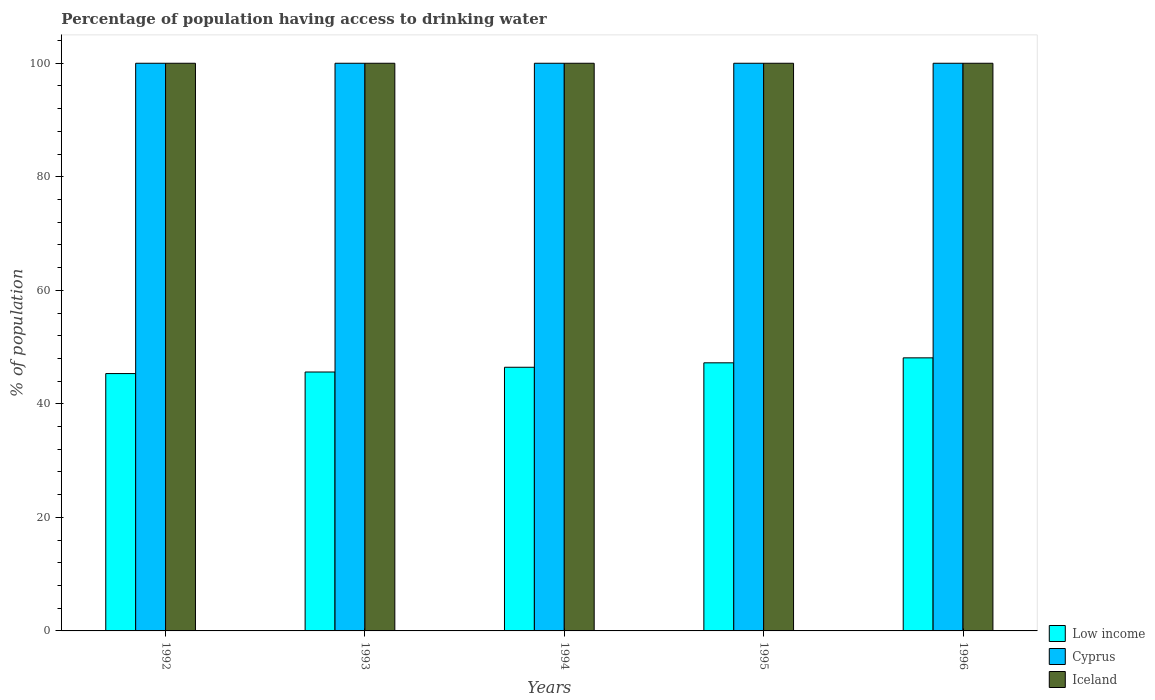Are the number of bars per tick equal to the number of legend labels?
Make the answer very short. Yes. Are the number of bars on each tick of the X-axis equal?
Give a very brief answer. Yes. What is the label of the 2nd group of bars from the left?
Provide a succinct answer. 1993. What is the percentage of population having access to drinking water in Low income in 1994?
Provide a short and direct response. 46.45. Across all years, what is the maximum percentage of population having access to drinking water in Low income?
Provide a succinct answer. 48.1. Across all years, what is the minimum percentage of population having access to drinking water in Cyprus?
Offer a terse response. 100. In which year was the percentage of population having access to drinking water in Low income maximum?
Keep it short and to the point. 1996. In which year was the percentage of population having access to drinking water in Iceland minimum?
Offer a very short reply. 1992. What is the total percentage of population having access to drinking water in Cyprus in the graph?
Offer a very short reply. 500. What is the difference between the percentage of population having access to drinking water in Low income in 1992 and the percentage of population having access to drinking water in Cyprus in 1995?
Offer a terse response. -54.67. In the year 1992, what is the difference between the percentage of population having access to drinking water in Low income and percentage of population having access to drinking water in Iceland?
Give a very brief answer. -54.67. In how many years, is the percentage of population having access to drinking water in Iceland greater than 52 %?
Make the answer very short. 5. Is the percentage of population having access to drinking water in Iceland in 1993 less than that in 1994?
Make the answer very short. No. Is the difference between the percentage of population having access to drinking water in Low income in 1995 and 1996 greater than the difference between the percentage of population having access to drinking water in Iceland in 1995 and 1996?
Make the answer very short. No. What is the difference between the highest and the lowest percentage of population having access to drinking water in Iceland?
Make the answer very short. 0. What does the 3rd bar from the left in 1996 represents?
Make the answer very short. Iceland. Is it the case that in every year, the sum of the percentage of population having access to drinking water in Cyprus and percentage of population having access to drinking water in Iceland is greater than the percentage of population having access to drinking water in Low income?
Ensure brevity in your answer.  Yes. How many bars are there?
Your response must be concise. 15. Are all the bars in the graph horizontal?
Your answer should be compact. No. Where does the legend appear in the graph?
Ensure brevity in your answer.  Bottom right. What is the title of the graph?
Make the answer very short. Percentage of population having access to drinking water. What is the label or title of the X-axis?
Your answer should be very brief. Years. What is the label or title of the Y-axis?
Offer a very short reply. % of population. What is the % of population in Low income in 1992?
Ensure brevity in your answer.  45.33. What is the % of population in Low income in 1993?
Provide a short and direct response. 45.61. What is the % of population of Low income in 1994?
Ensure brevity in your answer.  46.45. What is the % of population in Cyprus in 1994?
Give a very brief answer. 100. What is the % of population in Iceland in 1994?
Offer a terse response. 100. What is the % of population of Low income in 1995?
Make the answer very short. 47.23. What is the % of population of Iceland in 1995?
Give a very brief answer. 100. What is the % of population in Low income in 1996?
Keep it short and to the point. 48.1. What is the % of population of Cyprus in 1996?
Your answer should be very brief. 100. Across all years, what is the maximum % of population in Low income?
Your response must be concise. 48.1. Across all years, what is the maximum % of population of Cyprus?
Give a very brief answer. 100. Across all years, what is the minimum % of population of Low income?
Your response must be concise. 45.33. What is the total % of population in Low income in the graph?
Offer a terse response. 232.72. What is the total % of population of Cyprus in the graph?
Ensure brevity in your answer.  500. What is the difference between the % of population in Low income in 1992 and that in 1993?
Offer a terse response. -0.27. What is the difference between the % of population of Low income in 1992 and that in 1994?
Offer a terse response. -1.11. What is the difference between the % of population of Iceland in 1992 and that in 1994?
Make the answer very short. 0. What is the difference between the % of population in Low income in 1992 and that in 1995?
Provide a succinct answer. -1.9. What is the difference between the % of population in Cyprus in 1992 and that in 1995?
Make the answer very short. 0. What is the difference between the % of population in Low income in 1992 and that in 1996?
Provide a succinct answer. -2.77. What is the difference between the % of population in Iceland in 1992 and that in 1996?
Keep it short and to the point. 0. What is the difference between the % of population of Low income in 1993 and that in 1994?
Provide a succinct answer. -0.84. What is the difference between the % of population of Iceland in 1993 and that in 1994?
Ensure brevity in your answer.  0. What is the difference between the % of population of Low income in 1993 and that in 1995?
Offer a very short reply. -1.62. What is the difference between the % of population of Cyprus in 1993 and that in 1995?
Your answer should be very brief. 0. What is the difference between the % of population in Iceland in 1993 and that in 1995?
Offer a very short reply. 0. What is the difference between the % of population in Low income in 1993 and that in 1996?
Make the answer very short. -2.5. What is the difference between the % of population in Low income in 1994 and that in 1995?
Ensure brevity in your answer.  -0.78. What is the difference between the % of population of Cyprus in 1994 and that in 1995?
Your response must be concise. 0. What is the difference between the % of population of Iceland in 1994 and that in 1995?
Give a very brief answer. 0. What is the difference between the % of population of Low income in 1994 and that in 1996?
Ensure brevity in your answer.  -1.66. What is the difference between the % of population in Cyprus in 1994 and that in 1996?
Make the answer very short. 0. What is the difference between the % of population in Iceland in 1994 and that in 1996?
Your answer should be compact. 0. What is the difference between the % of population of Low income in 1995 and that in 1996?
Keep it short and to the point. -0.88. What is the difference between the % of population of Iceland in 1995 and that in 1996?
Provide a succinct answer. 0. What is the difference between the % of population of Low income in 1992 and the % of population of Cyprus in 1993?
Your response must be concise. -54.67. What is the difference between the % of population of Low income in 1992 and the % of population of Iceland in 1993?
Your answer should be compact. -54.67. What is the difference between the % of population of Cyprus in 1992 and the % of population of Iceland in 1993?
Give a very brief answer. 0. What is the difference between the % of population in Low income in 1992 and the % of population in Cyprus in 1994?
Keep it short and to the point. -54.67. What is the difference between the % of population of Low income in 1992 and the % of population of Iceland in 1994?
Ensure brevity in your answer.  -54.67. What is the difference between the % of population in Low income in 1992 and the % of population in Cyprus in 1995?
Your answer should be very brief. -54.67. What is the difference between the % of population in Low income in 1992 and the % of population in Iceland in 1995?
Your answer should be very brief. -54.67. What is the difference between the % of population in Cyprus in 1992 and the % of population in Iceland in 1995?
Provide a succinct answer. 0. What is the difference between the % of population in Low income in 1992 and the % of population in Cyprus in 1996?
Your answer should be compact. -54.67. What is the difference between the % of population of Low income in 1992 and the % of population of Iceland in 1996?
Your answer should be very brief. -54.67. What is the difference between the % of population in Cyprus in 1992 and the % of population in Iceland in 1996?
Provide a short and direct response. 0. What is the difference between the % of population of Low income in 1993 and the % of population of Cyprus in 1994?
Your answer should be very brief. -54.39. What is the difference between the % of population of Low income in 1993 and the % of population of Iceland in 1994?
Make the answer very short. -54.39. What is the difference between the % of population in Cyprus in 1993 and the % of population in Iceland in 1994?
Ensure brevity in your answer.  0. What is the difference between the % of population of Low income in 1993 and the % of population of Cyprus in 1995?
Your answer should be very brief. -54.39. What is the difference between the % of population of Low income in 1993 and the % of population of Iceland in 1995?
Your answer should be very brief. -54.39. What is the difference between the % of population in Low income in 1993 and the % of population in Cyprus in 1996?
Offer a very short reply. -54.39. What is the difference between the % of population of Low income in 1993 and the % of population of Iceland in 1996?
Provide a short and direct response. -54.39. What is the difference between the % of population in Cyprus in 1993 and the % of population in Iceland in 1996?
Your response must be concise. 0. What is the difference between the % of population of Low income in 1994 and the % of population of Cyprus in 1995?
Offer a very short reply. -53.55. What is the difference between the % of population in Low income in 1994 and the % of population in Iceland in 1995?
Keep it short and to the point. -53.55. What is the difference between the % of population in Low income in 1994 and the % of population in Cyprus in 1996?
Make the answer very short. -53.55. What is the difference between the % of population of Low income in 1994 and the % of population of Iceland in 1996?
Offer a terse response. -53.55. What is the difference between the % of population in Cyprus in 1994 and the % of population in Iceland in 1996?
Make the answer very short. 0. What is the difference between the % of population in Low income in 1995 and the % of population in Cyprus in 1996?
Make the answer very short. -52.77. What is the difference between the % of population of Low income in 1995 and the % of population of Iceland in 1996?
Offer a very short reply. -52.77. What is the difference between the % of population of Cyprus in 1995 and the % of population of Iceland in 1996?
Ensure brevity in your answer.  0. What is the average % of population in Low income per year?
Ensure brevity in your answer.  46.54. In the year 1992, what is the difference between the % of population of Low income and % of population of Cyprus?
Your answer should be compact. -54.67. In the year 1992, what is the difference between the % of population in Low income and % of population in Iceland?
Make the answer very short. -54.67. In the year 1993, what is the difference between the % of population of Low income and % of population of Cyprus?
Your answer should be very brief. -54.39. In the year 1993, what is the difference between the % of population of Low income and % of population of Iceland?
Provide a succinct answer. -54.39. In the year 1993, what is the difference between the % of population in Cyprus and % of population in Iceland?
Provide a short and direct response. 0. In the year 1994, what is the difference between the % of population of Low income and % of population of Cyprus?
Provide a succinct answer. -53.55. In the year 1994, what is the difference between the % of population in Low income and % of population in Iceland?
Your response must be concise. -53.55. In the year 1994, what is the difference between the % of population of Cyprus and % of population of Iceland?
Offer a very short reply. 0. In the year 1995, what is the difference between the % of population in Low income and % of population in Cyprus?
Provide a short and direct response. -52.77. In the year 1995, what is the difference between the % of population of Low income and % of population of Iceland?
Your answer should be very brief. -52.77. In the year 1996, what is the difference between the % of population of Low income and % of population of Cyprus?
Offer a terse response. -51.9. In the year 1996, what is the difference between the % of population in Low income and % of population in Iceland?
Give a very brief answer. -51.9. In the year 1996, what is the difference between the % of population in Cyprus and % of population in Iceland?
Your response must be concise. 0. What is the ratio of the % of population in Low income in 1992 to that in 1993?
Your answer should be compact. 0.99. What is the ratio of the % of population in Iceland in 1992 to that in 1993?
Your answer should be very brief. 1. What is the ratio of the % of population in Low income in 1992 to that in 1994?
Your answer should be compact. 0.98. What is the ratio of the % of population in Cyprus in 1992 to that in 1994?
Your response must be concise. 1. What is the ratio of the % of population in Iceland in 1992 to that in 1994?
Provide a short and direct response. 1. What is the ratio of the % of population of Low income in 1992 to that in 1995?
Make the answer very short. 0.96. What is the ratio of the % of population of Iceland in 1992 to that in 1995?
Your answer should be very brief. 1. What is the ratio of the % of population of Low income in 1992 to that in 1996?
Keep it short and to the point. 0.94. What is the ratio of the % of population in Cyprus in 1992 to that in 1996?
Your answer should be very brief. 1. What is the ratio of the % of population of Iceland in 1992 to that in 1996?
Make the answer very short. 1. What is the ratio of the % of population of Low income in 1993 to that in 1994?
Offer a terse response. 0.98. What is the ratio of the % of population in Low income in 1993 to that in 1995?
Make the answer very short. 0.97. What is the ratio of the % of population of Iceland in 1993 to that in 1995?
Provide a succinct answer. 1. What is the ratio of the % of population in Low income in 1993 to that in 1996?
Offer a terse response. 0.95. What is the ratio of the % of population of Low income in 1994 to that in 1995?
Provide a succinct answer. 0.98. What is the ratio of the % of population in Cyprus in 1994 to that in 1995?
Your answer should be very brief. 1. What is the ratio of the % of population in Low income in 1994 to that in 1996?
Keep it short and to the point. 0.97. What is the ratio of the % of population in Cyprus in 1994 to that in 1996?
Offer a very short reply. 1. What is the ratio of the % of population in Low income in 1995 to that in 1996?
Keep it short and to the point. 0.98. What is the ratio of the % of population of Iceland in 1995 to that in 1996?
Offer a terse response. 1. What is the difference between the highest and the second highest % of population in Low income?
Your answer should be compact. 0.88. What is the difference between the highest and the second highest % of population in Iceland?
Your response must be concise. 0. What is the difference between the highest and the lowest % of population of Low income?
Provide a succinct answer. 2.77. 